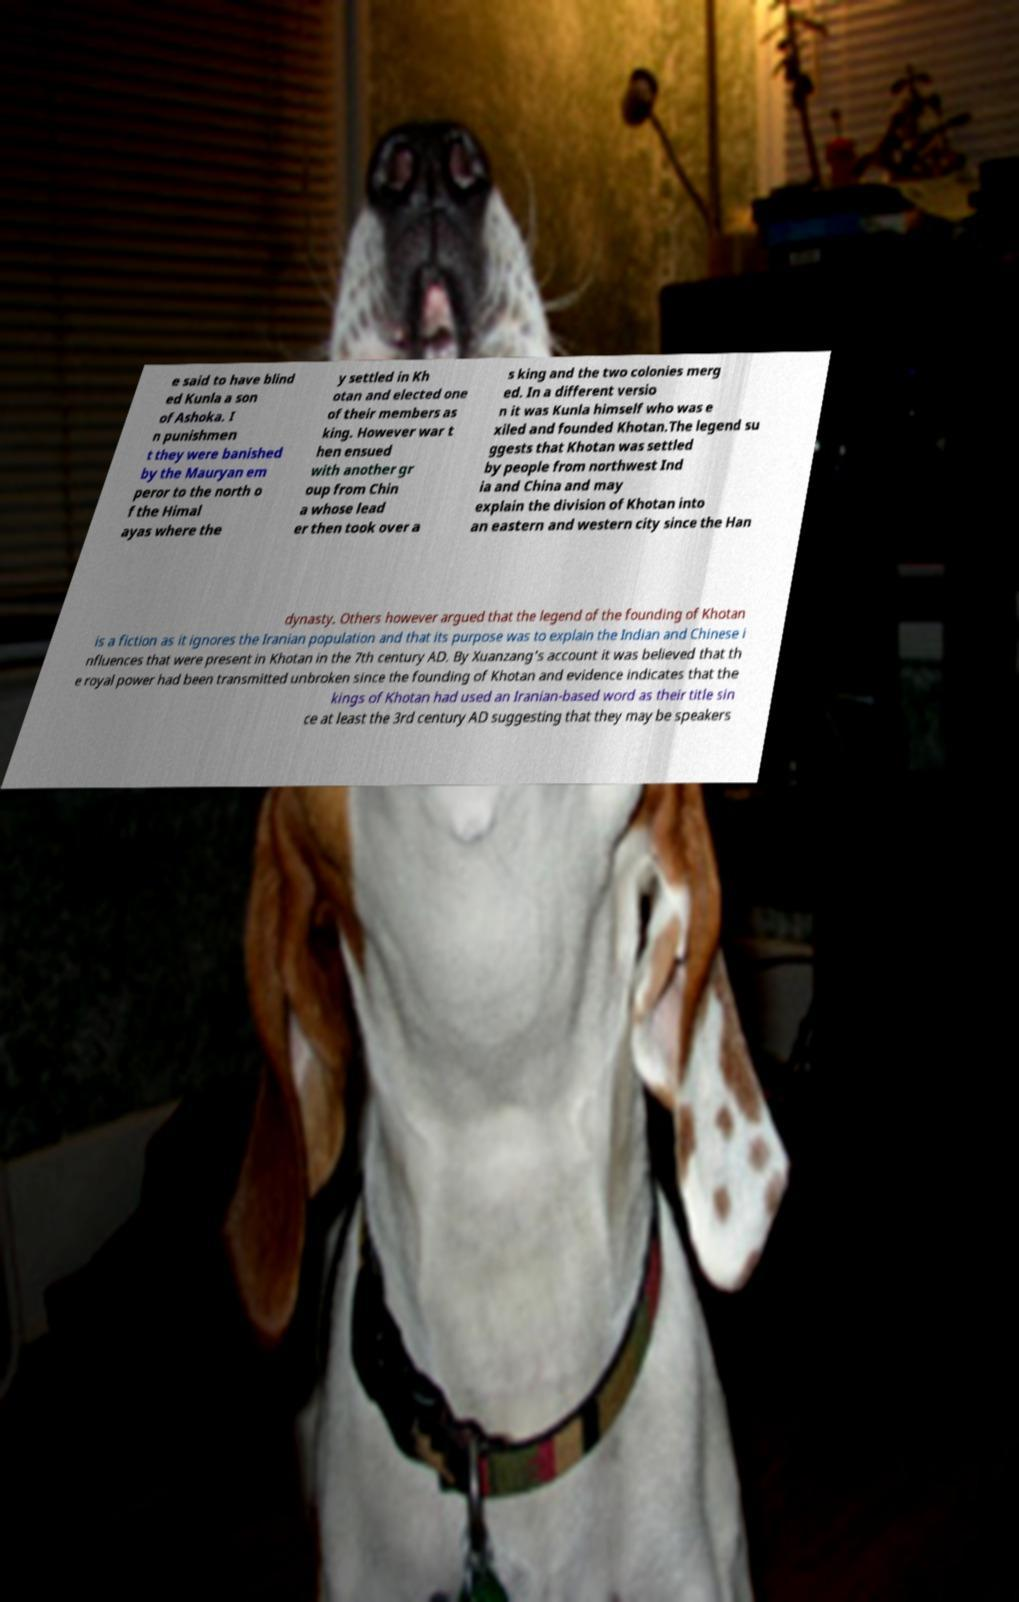Please read and relay the text visible in this image. What does it say? e said to have blind ed Kunla a son of Ashoka. I n punishmen t they were banished by the Mauryan em peror to the north o f the Himal ayas where the y settled in Kh otan and elected one of their members as king. However war t hen ensued with another gr oup from Chin a whose lead er then took over a s king and the two colonies merg ed. In a different versio n it was Kunla himself who was e xiled and founded Khotan.The legend su ggests that Khotan was settled by people from northwest Ind ia and China and may explain the division of Khotan into an eastern and western city since the Han dynasty. Others however argued that the legend of the founding of Khotan is a fiction as it ignores the Iranian population and that its purpose was to explain the Indian and Chinese i nfluences that were present in Khotan in the 7th century AD. By Xuanzang's account it was believed that th e royal power had been transmitted unbroken since the founding of Khotan and evidence indicates that the kings of Khotan had used an Iranian-based word as their title sin ce at least the 3rd century AD suggesting that they may be speakers 